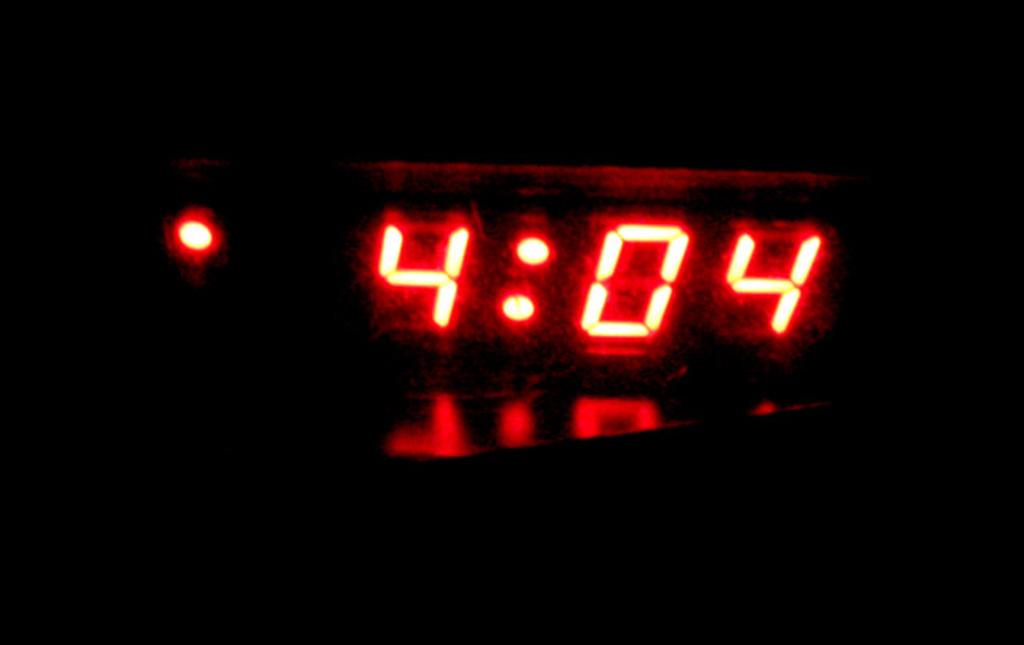What is the time on the clock?
Offer a terse response. 4:04. 